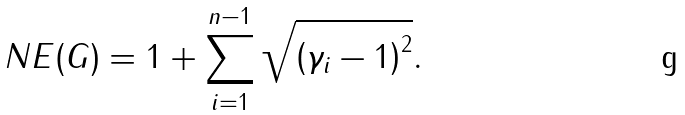<formula> <loc_0><loc_0><loc_500><loc_500>N E ( G ) = 1 + \sum _ { i = 1 } ^ { n - 1 } \sqrt { \left ( \gamma _ { i } - 1 \right ) ^ { 2 } } .</formula> 